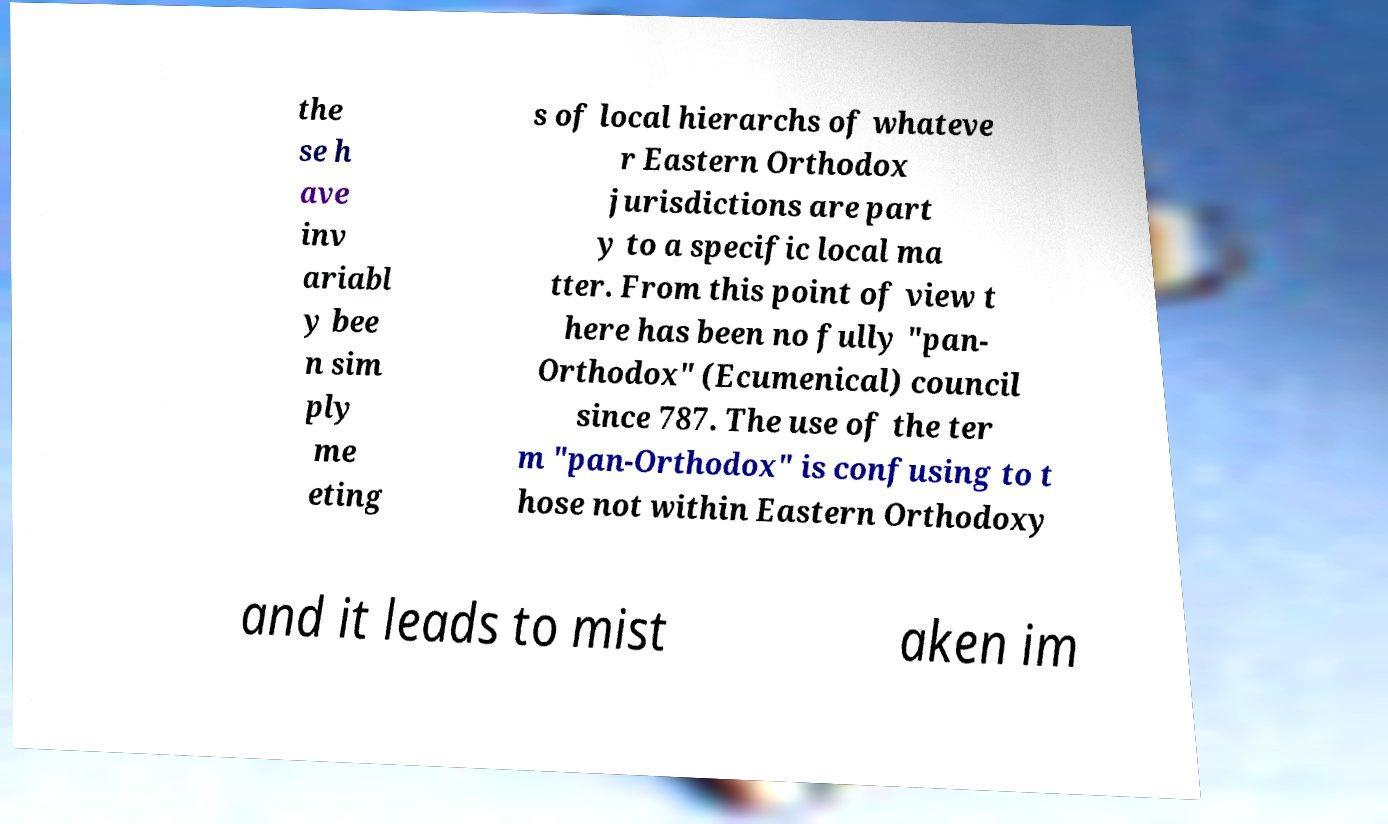Please read and relay the text visible in this image. What does it say? the se h ave inv ariabl y bee n sim ply me eting s of local hierarchs of whateve r Eastern Orthodox jurisdictions are part y to a specific local ma tter. From this point of view t here has been no fully "pan- Orthodox" (Ecumenical) council since 787. The use of the ter m "pan-Orthodox" is confusing to t hose not within Eastern Orthodoxy and it leads to mist aken im 